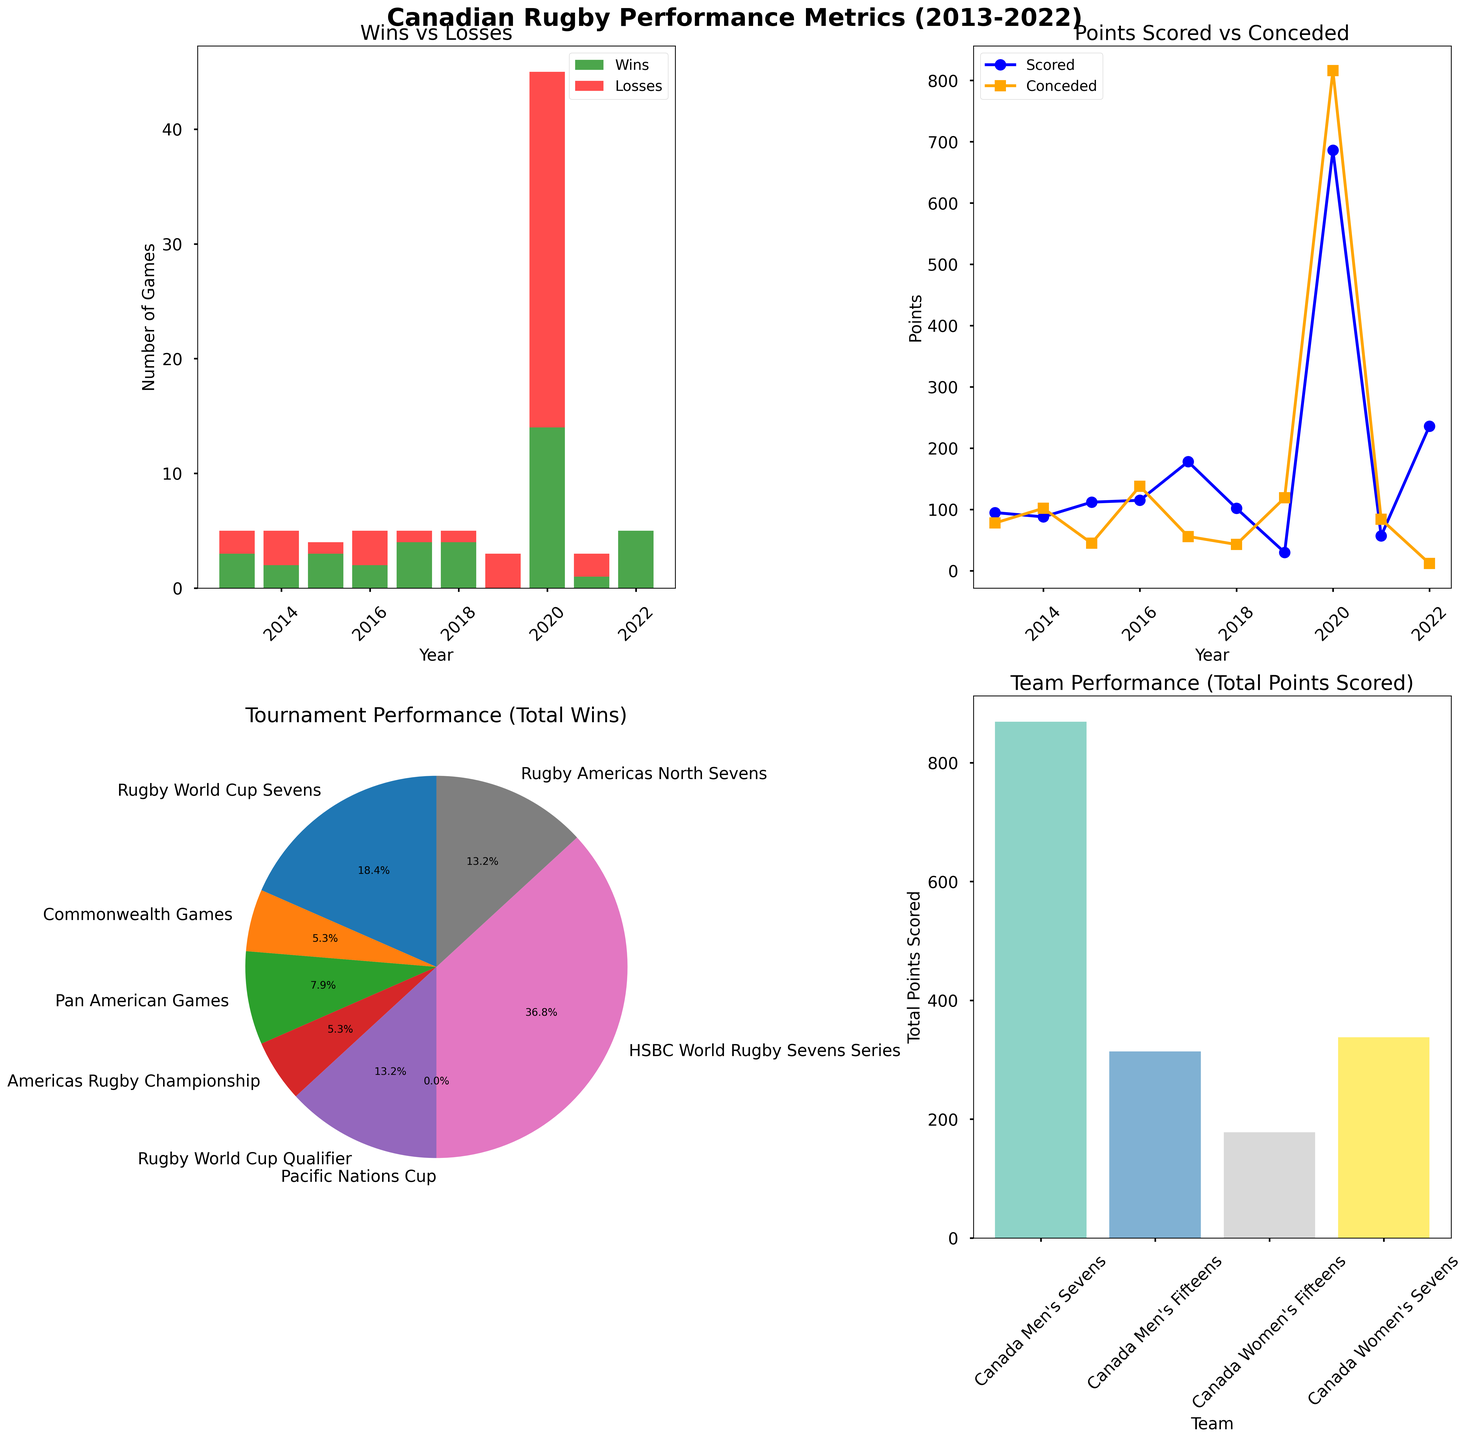What is the title of the subplot in the top left corner? The subplot in the top left corner has a title at the top. It states "Wins vs Losses."
Answer: Wins vs Losses Which year shows the highest number of Wins? In the "Wins vs Losses" subplot, look for the bar with the tallest green segment. The year with the most wins is 2020.
Answer: 2020 How many points were scored by Canadian teams in 2015? Locate the point on the "Points Scored vs Conceded" plot corresponding to the year 2015. The y-axis value for the blue line at this point is 112.
Answer: 112 In which year did Canada men’s teams concede the least points? Examine the orange line on the "Points Scored vs Conceded" plot and find the lowest point along the y-axis. The year corresponding to this point is 2015.
Answer: 2015 Which tournament contributed the highest percentage of total wins? Refer to the "Tournament Performance (Total Wins)" pie chart. Look for the largest pie slice. The tournament with the highest percentage of total wins is the Rugby Americas North Sevens.
Answer: Rugby Americas North Sevens What is the total number of points scored by Canada Women's Sevens team? In the "Team Performance (Total Points Scored)" bar chart, find the bar for "Canada Women's Sevens" and read off the value on the y-axis, which is 338.
Answer: 338 Compare the points conceded by Canadian teams in 2014 and 2021. In which year did they concede more? Check the "Points Scored vs Conceded" plot. For the years 2014 and 2021, the points conceded (orange line) are higher in 2014 (102) compared to 2021 (84).
Answer: 2014 What is the sum of the wins for 2018 and 2022? Locate the wins for the years 2018 and 2022 in the "Wins vs Losses" subplot. The sum is 4 + 5 = 9.
Answer: 9 Which team scored the highest total points? In the "Team Performance (Total Points Scored)" bar chart, identify the bar that reaches the highest point on the y-axis. The team is "Canada Men's Sevens."
Answer: Canada Men's Sevens 